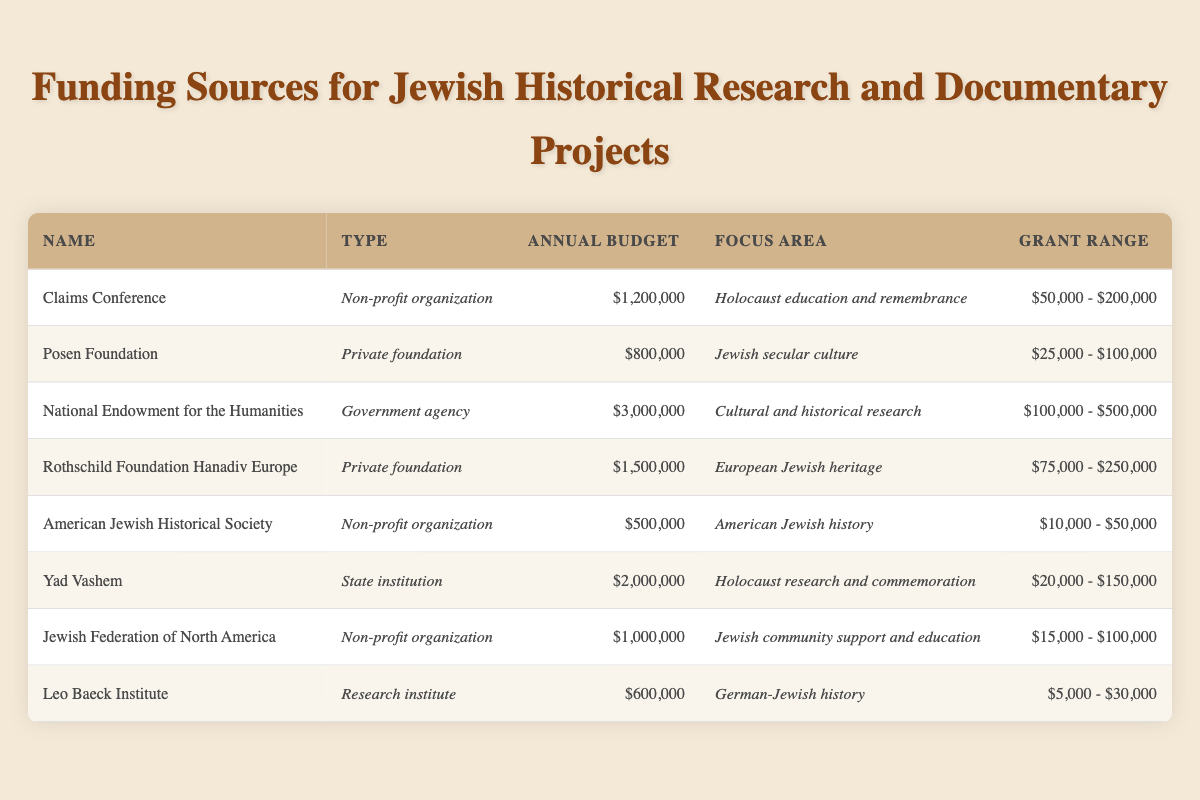What is the annual budget of the National Endowment for the Humanities? The table shows that the annual budget for the National Endowment for the Humanities is listed as $3,000,000.
Answer: $3,000,000 Which funding source has a focus area in Holocaust education and remembrance? By scanning the "Focus Area" column in the table, it is evident that the "Claims Conference" is specifically associated with Holocaust education and remembrance.
Answer: Claims Conference What is the grant range for the Rothschild Foundation Hanadiv Europe? The table clearly states that the Rothschild Foundation Hanadiv Europe has a grant range listed as $75,000 - $250,000.
Answer: $75,000 - $250,000 Is the annual budget of Yad Vashem higher than that of the American Jewish Historical Society? Comparing the annual budgets in the table, Yad Vashem's budget is $2,000,000 while the American Jewish Historical Society's budget is $500,000. Since $2,000,000 is greater than $500,000, the answer is yes.
Answer: Yes What is the average annual budget of all the funding sources listed? To find the average, we first sum the annual budgets: $1,200,000 + $800,000 + $3,000,000 + $1,500,000 + $500,000 + $2,000,000 + $1,000,000 + $600,000 = $10,600,000. Next, divide by the number of funding sources, which is 8. Therefore, the average is $10,600,000 / 8 = $1,325,000.
Answer: $1,325,000 How many funding sources are categorized as non-profit organizations? By reviewing the table, we identify that there are 4 non-profit organizations: Claims Conference, American Jewish Historical Society, Jewish Federation of North America, and Yad Vashem. Thus, the answer is 4.
Answer: 4 